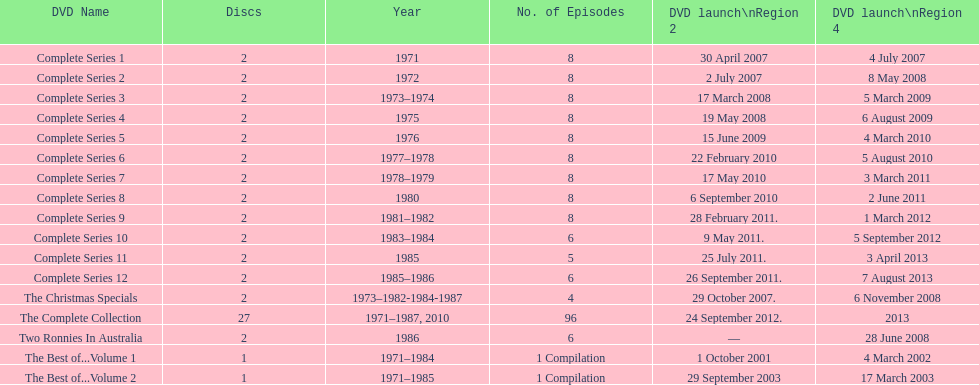How many "best of" volumes compile the top episodes of the television show "the two ronnies". 2. 